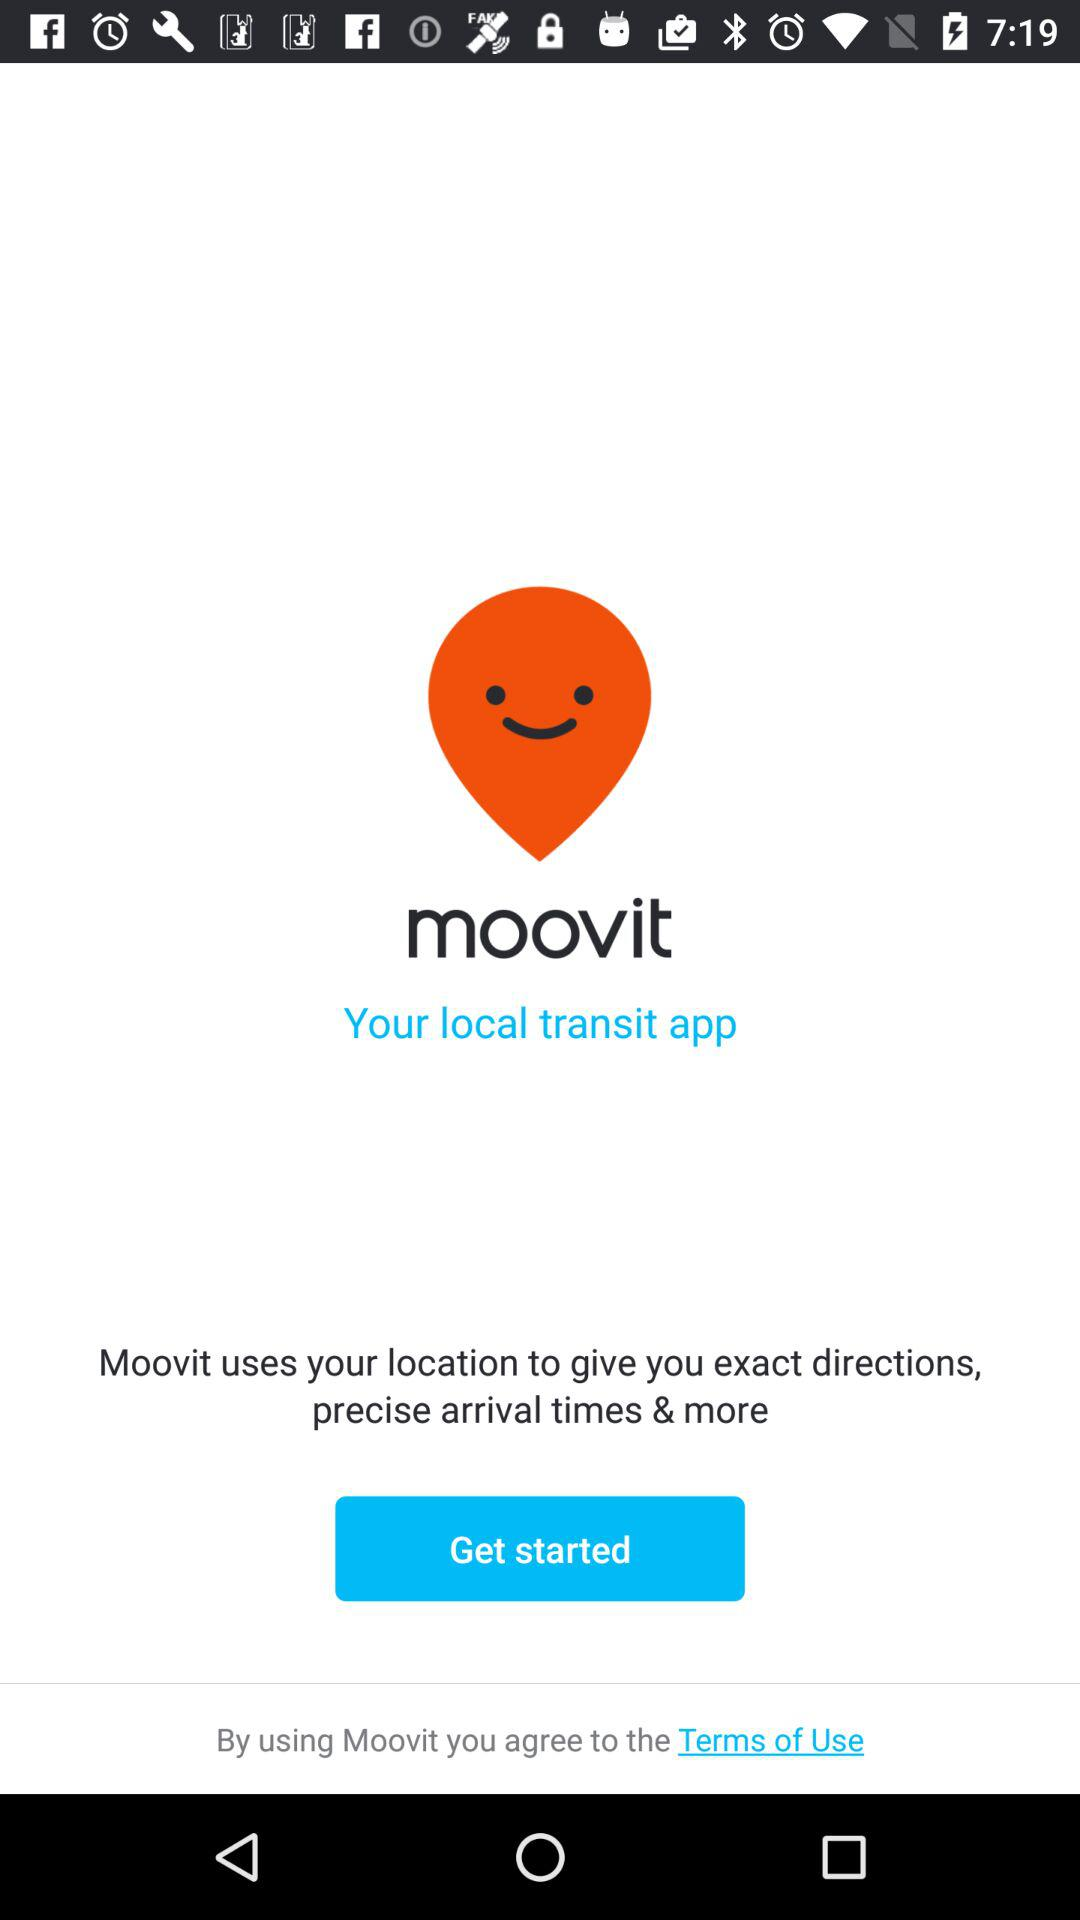What app can be used for local transit? For local transit, the app "moovit" can be used. 